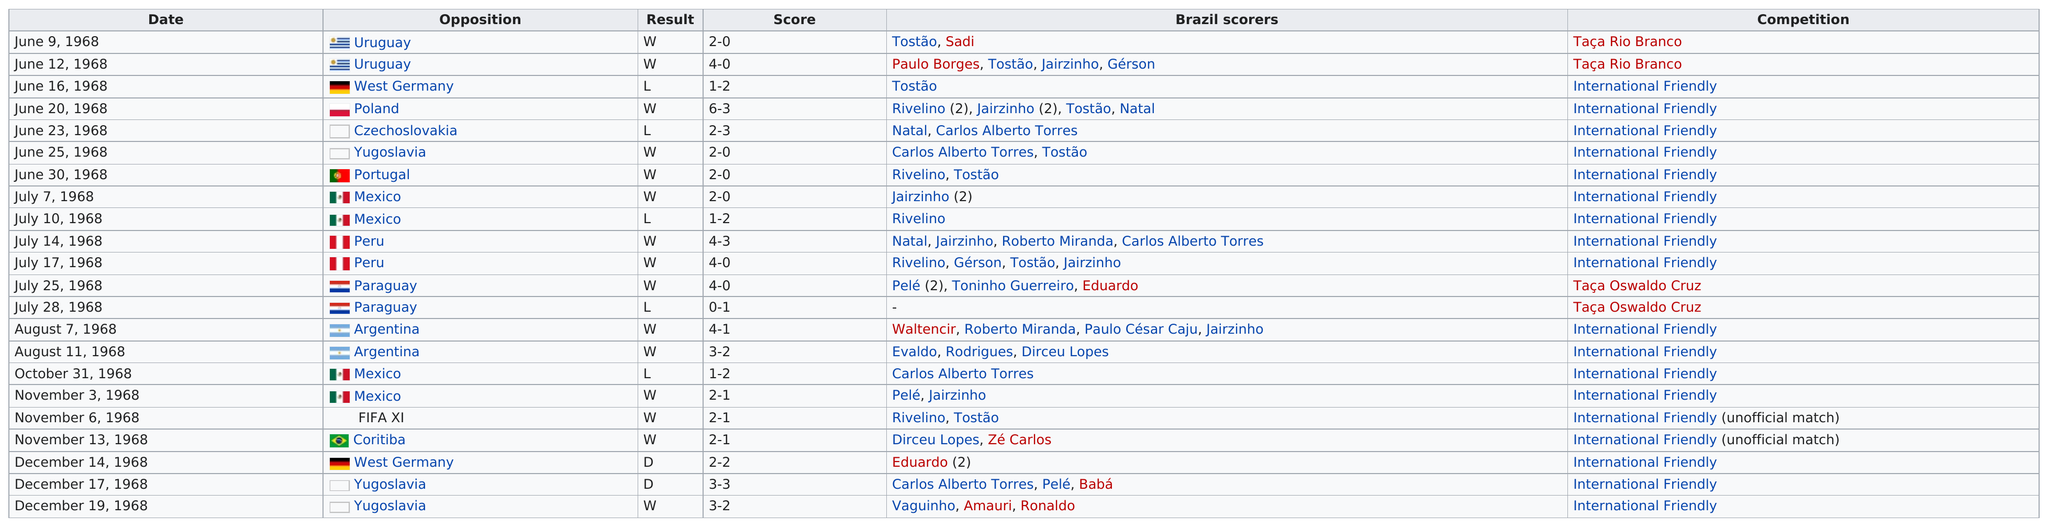Point out several critical features in this image. The Brazil National Team has achieved a top score of six. The highest scoring game was in 1968. The Brazilian team played against Yugoslavia prior to the game on June 30th. Of the 15 matches, how many were wins? Brazil and Argentina have faced each other in a number of international friendly competitions, with the exact number of matches played being two. 